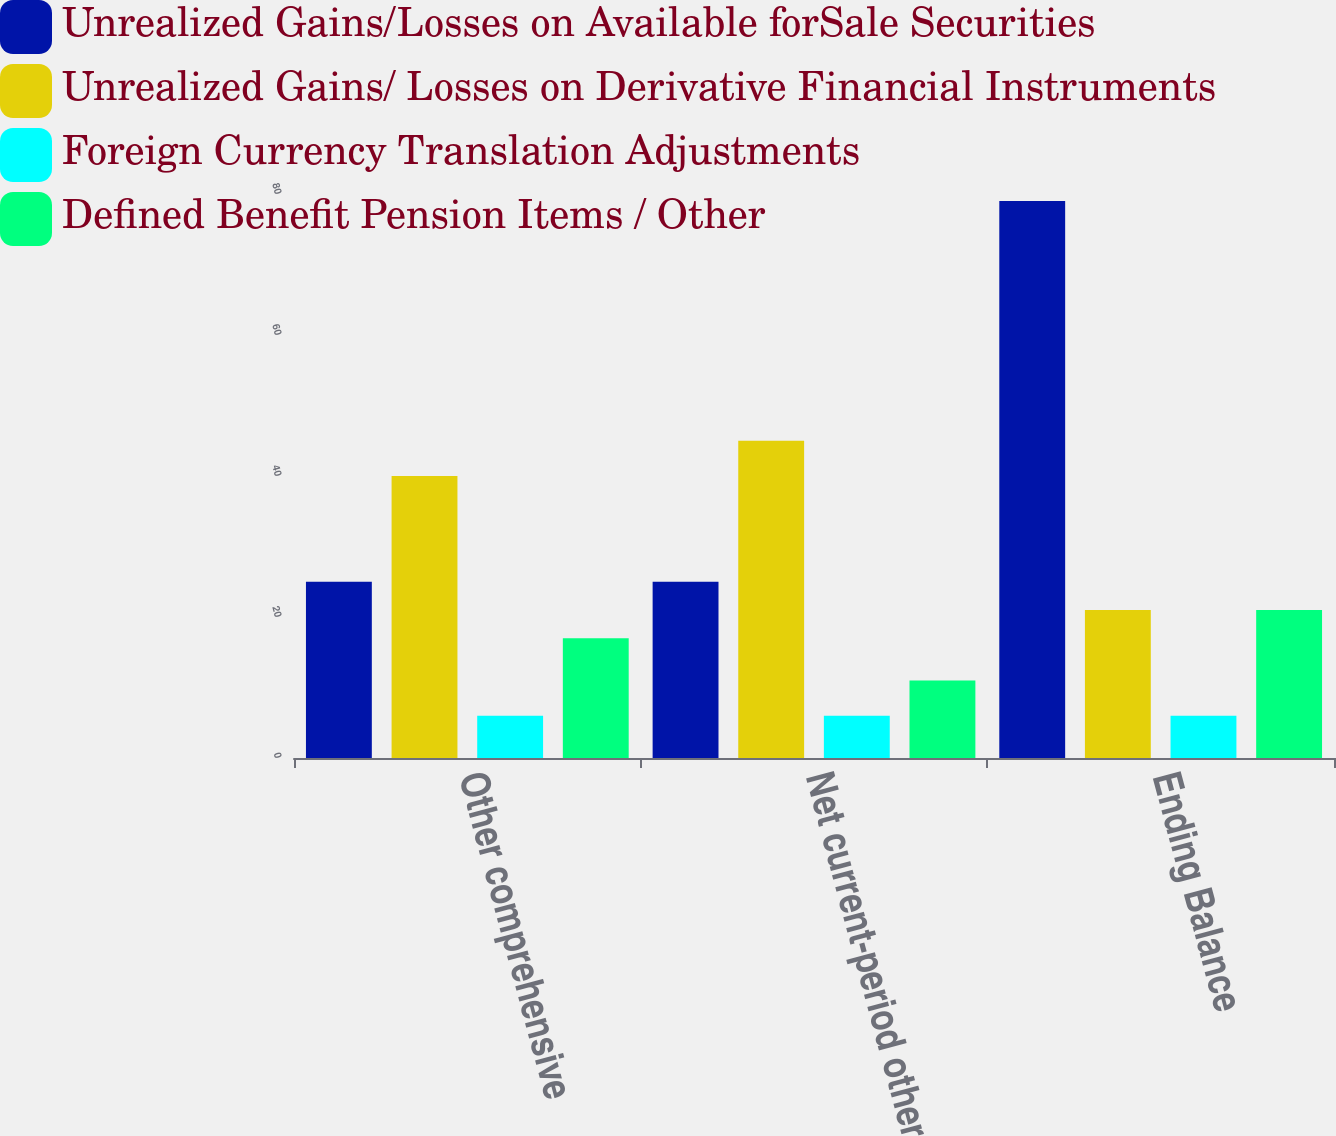Convert chart to OTSL. <chart><loc_0><loc_0><loc_500><loc_500><stacked_bar_chart><ecel><fcel>Other comprehensive<fcel>Net current-period other<fcel>Ending Balance<nl><fcel>Unrealized Gains/Losses on Available forSale Securities<fcel>25<fcel>25<fcel>79<nl><fcel>Unrealized Gains/ Losses on Derivative Financial Instruments<fcel>40<fcel>45<fcel>21<nl><fcel>Foreign Currency Translation Adjustments<fcel>6<fcel>6<fcel>6<nl><fcel>Defined Benefit Pension Items / Other<fcel>17<fcel>11<fcel>21<nl></chart> 